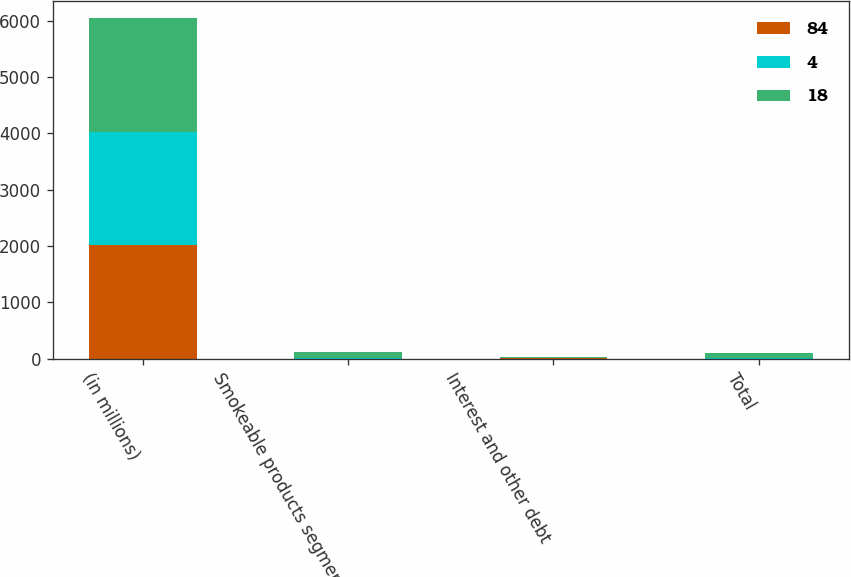<chart> <loc_0><loc_0><loc_500><loc_500><stacked_bar_chart><ecel><fcel>(in millions)<fcel>Smokeable products segment<fcel>Interest and other debt<fcel>Total<nl><fcel>84<fcel>2017<fcel>5<fcel>9<fcel>4<nl><fcel>4<fcel>2016<fcel>12<fcel>6<fcel>18<nl><fcel>18<fcel>2015<fcel>97<fcel>13<fcel>84<nl></chart> 